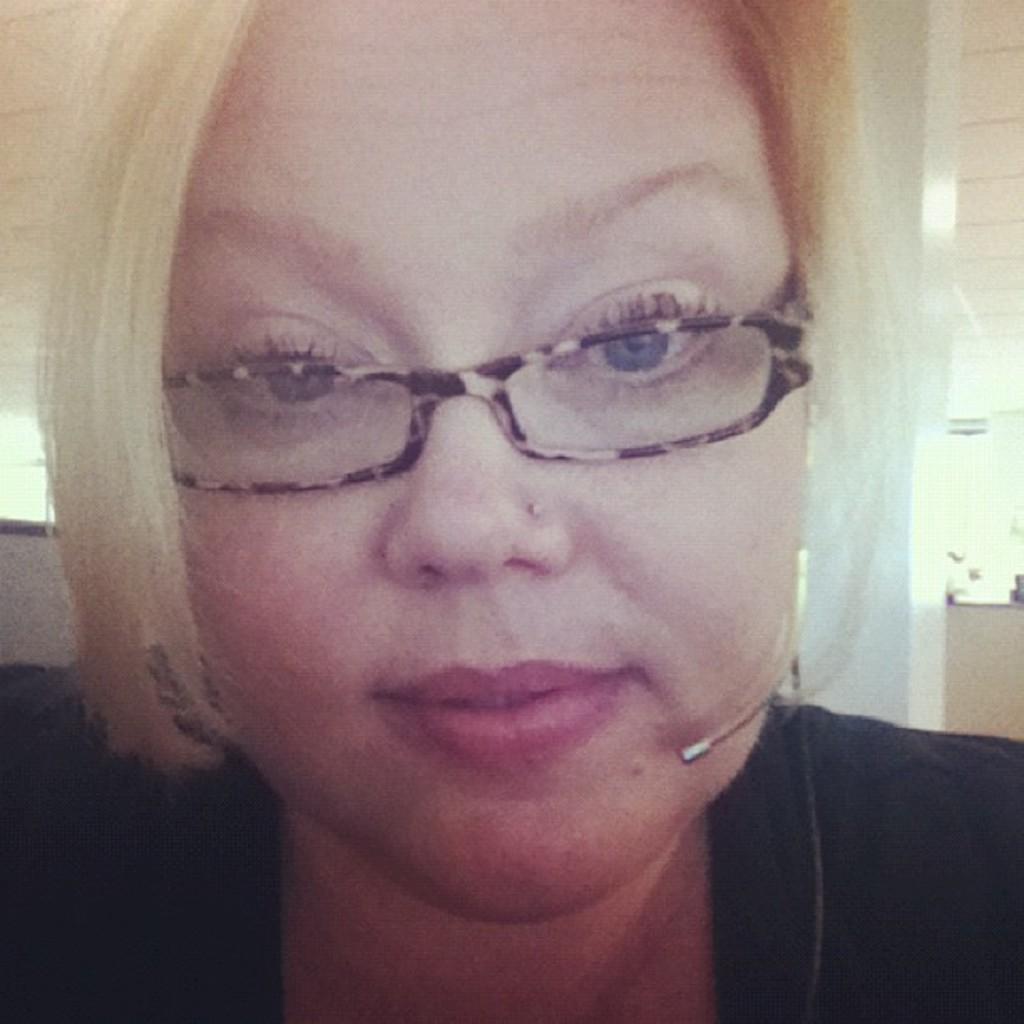Please provide a concise description of this image. In this picture we can see a woman wearing spectacles. 